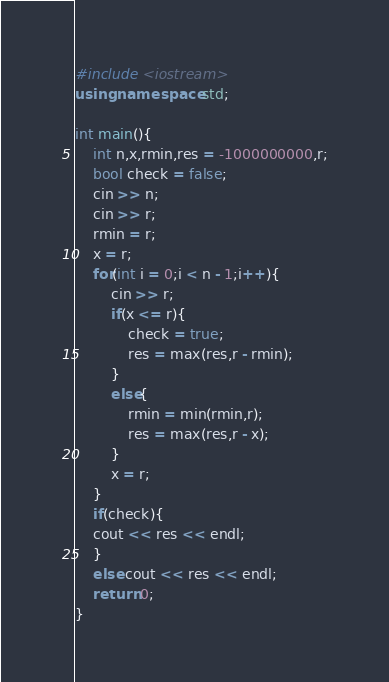Convert code to text. <code><loc_0><loc_0><loc_500><loc_500><_C++_>#include <iostream>
using namespace std;
 
int main(){
    int n,x,rmin,res = -1000000000,r;
    bool check = false;
    cin >> n;
    cin >> r;
    rmin = r;
    x = r;
    for(int i = 0;i < n - 1;i++){
        cin >> r;
        if(x <= r){
            check = true;
            res = max(res,r - rmin);
        }
        else{
            rmin = min(rmin,r);
            res = max(res,r - x);
        }
        x = r;
    }
    if(check){
    cout << res << endl;
    }
    else cout << res << endl;
    return 0;
}</code> 